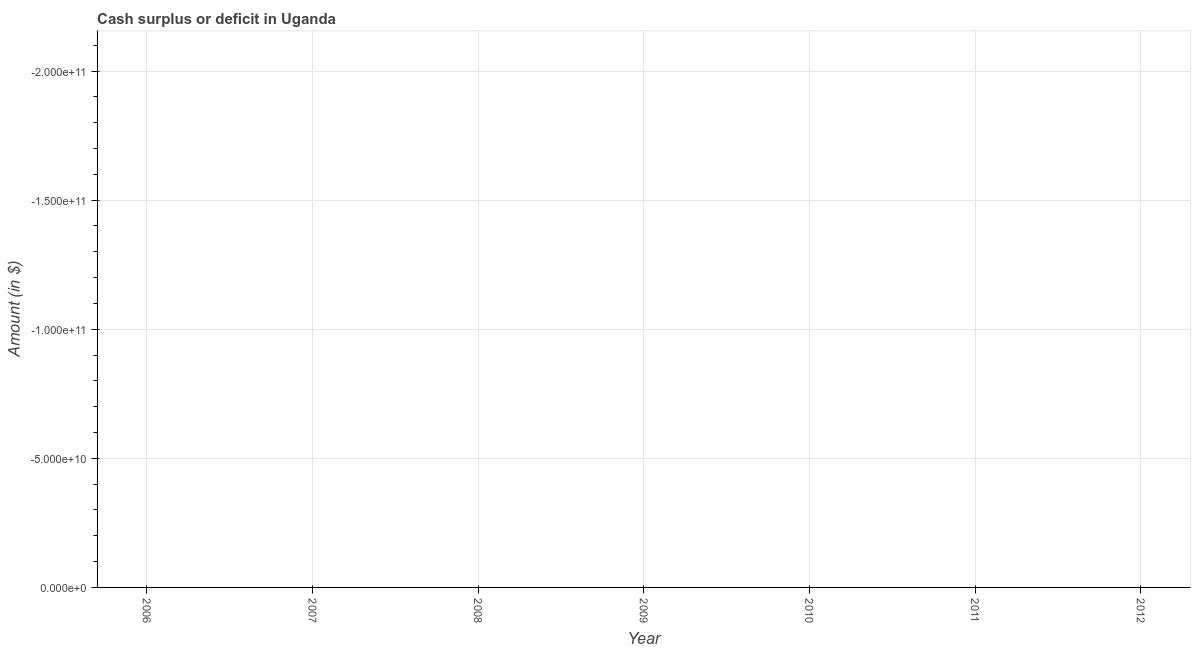What is the cash surplus or deficit in 2007?
Your answer should be compact. 0. Across all years, what is the minimum cash surplus or deficit?
Your answer should be very brief. 0. What is the average cash surplus or deficit per year?
Provide a short and direct response. 0. What is the median cash surplus or deficit?
Offer a very short reply. 0. In how many years, is the cash surplus or deficit greater than the average cash surplus or deficit taken over all years?
Offer a very short reply. 0. How many years are there in the graph?
Your answer should be compact. 7. What is the difference between two consecutive major ticks on the Y-axis?
Keep it short and to the point. 5.00e+1. What is the title of the graph?
Offer a terse response. Cash surplus or deficit in Uganda. What is the label or title of the Y-axis?
Your response must be concise. Amount (in $). What is the Amount (in $) in 2006?
Keep it short and to the point. 0. What is the Amount (in $) in 2008?
Your answer should be very brief. 0. What is the Amount (in $) in 2009?
Provide a succinct answer. 0. What is the Amount (in $) in 2010?
Provide a short and direct response. 0. What is the Amount (in $) in 2011?
Offer a terse response. 0. 